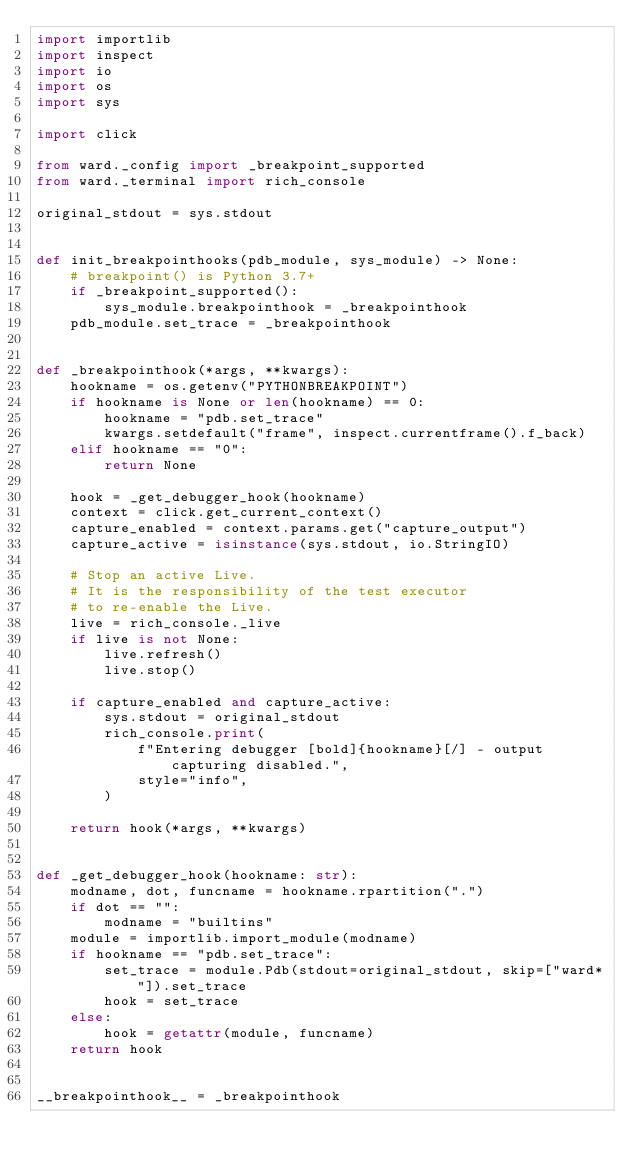<code> <loc_0><loc_0><loc_500><loc_500><_Python_>import importlib
import inspect
import io
import os
import sys

import click

from ward._config import _breakpoint_supported
from ward._terminal import rich_console

original_stdout = sys.stdout


def init_breakpointhooks(pdb_module, sys_module) -> None:
    # breakpoint() is Python 3.7+
    if _breakpoint_supported():
        sys_module.breakpointhook = _breakpointhook
    pdb_module.set_trace = _breakpointhook


def _breakpointhook(*args, **kwargs):
    hookname = os.getenv("PYTHONBREAKPOINT")
    if hookname is None or len(hookname) == 0:
        hookname = "pdb.set_trace"
        kwargs.setdefault("frame", inspect.currentframe().f_back)
    elif hookname == "0":
        return None

    hook = _get_debugger_hook(hookname)
    context = click.get_current_context()
    capture_enabled = context.params.get("capture_output")
    capture_active = isinstance(sys.stdout, io.StringIO)

    # Stop an active Live.
    # It is the responsibility of the test executor
    # to re-enable the Live.
    live = rich_console._live
    if live is not None:
        live.refresh()
        live.stop()

    if capture_enabled and capture_active:
        sys.stdout = original_stdout
        rich_console.print(
            f"Entering debugger [bold]{hookname}[/] - output capturing disabled.",
            style="info",
        )

    return hook(*args, **kwargs)


def _get_debugger_hook(hookname: str):
    modname, dot, funcname = hookname.rpartition(".")
    if dot == "":
        modname = "builtins"
    module = importlib.import_module(modname)
    if hookname == "pdb.set_trace":
        set_trace = module.Pdb(stdout=original_stdout, skip=["ward*"]).set_trace
        hook = set_trace
    else:
        hook = getattr(module, funcname)
    return hook


__breakpointhook__ = _breakpointhook
</code> 